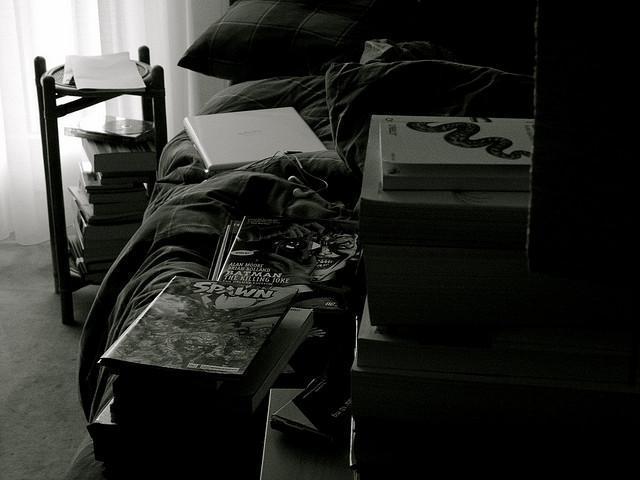How many books can you see?
Give a very brief answer. 5. How many dogs are sleeping?
Give a very brief answer. 0. 